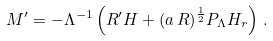Convert formula to latex. <formula><loc_0><loc_0><loc_500><loc_500>M ^ { \prime } = - \Lambda ^ { - 1 } \left ( R ^ { \prime } H + ( a \, R ) ^ { \frac { 1 } { 2 } } P _ { \Lambda } H _ { r } \right ) \, .</formula> 